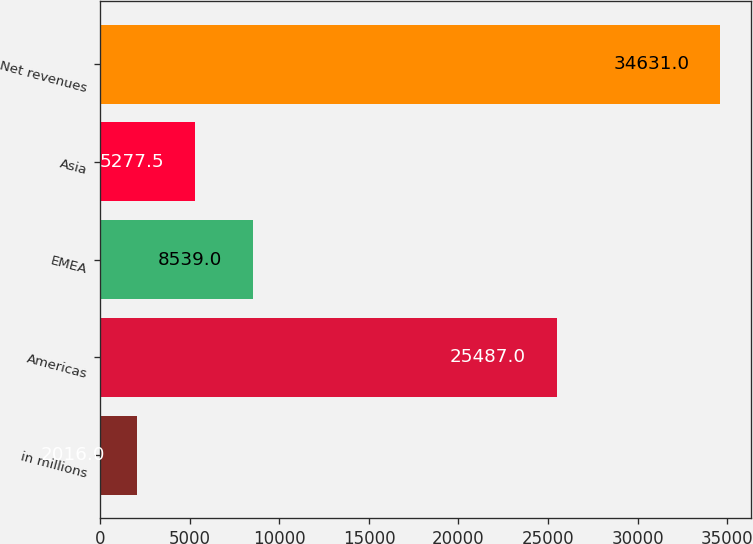Convert chart to OTSL. <chart><loc_0><loc_0><loc_500><loc_500><bar_chart><fcel>in millions<fcel>Americas<fcel>EMEA<fcel>Asia<fcel>Net revenues<nl><fcel>2016<fcel>25487<fcel>8539<fcel>5277.5<fcel>34631<nl></chart> 